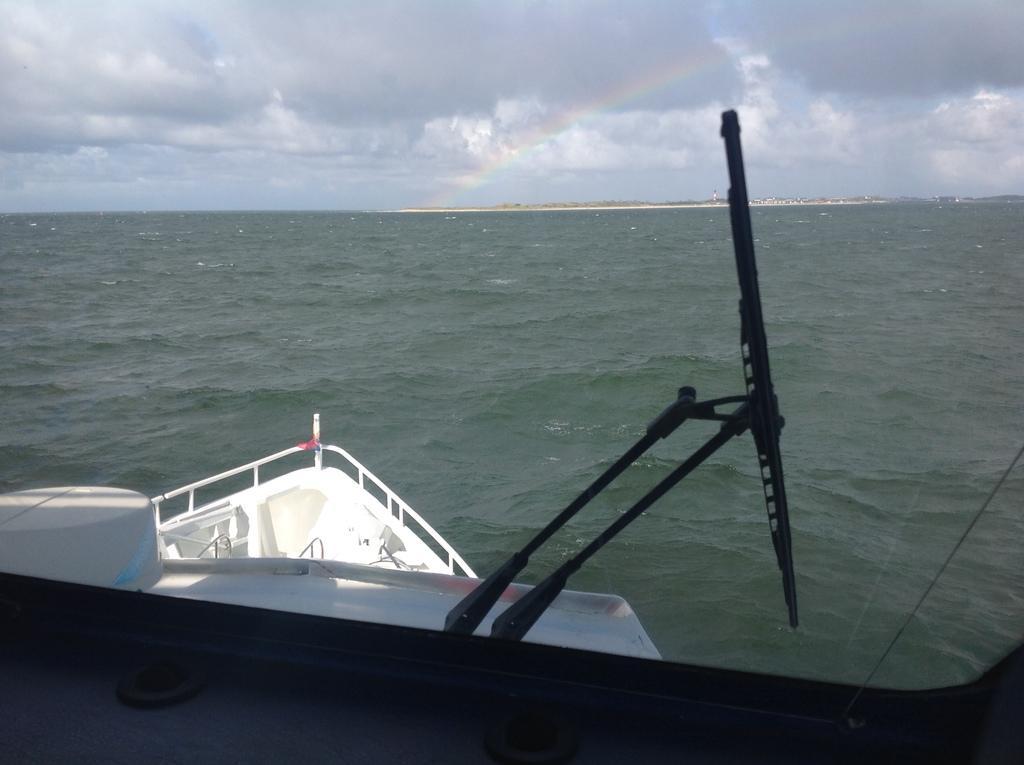Describe this image in one or two sentences. In this image in the foreground there might be ship, and in the ship there are some objects. And in the background there is a river, and at the top there is sky. 